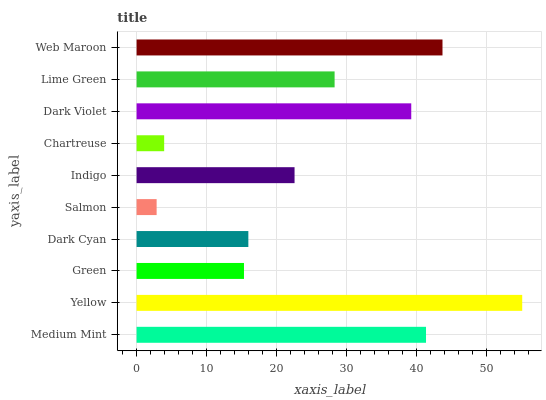Is Salmon the minimum?
Answer yes or no. Yes. Is Yellow the maximum?
Answer yes or no. Yes. Is Green the minimum?
Answer yes or no. No. Is Green the maximum?
Answer yes or no. No. Is Yellow greater than Green?
Answer yes or no. Yes. Is Green less than Yellow?
Answer yes or no. Yes. Is Green greater than Yellow?
Answer yes or no. No. Is Yellow less than Green?
Answer yes or no. No. Is Lime Green the high median?
Answer yes or no. Yes. Is Indigo the low median?
Answer yes or no. Yes. Is Yellow the high median?
Answer yes or no. No. Is Dark Cyan the low median?
Answer yes or no. No. 